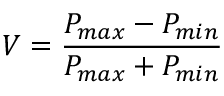<formula> <loc_0><loc_0><loc_500><loc_500>V = \frac { P _ { \max } - P _ { \min } } { P _ { \max } + P _ { \min } }</formula> 